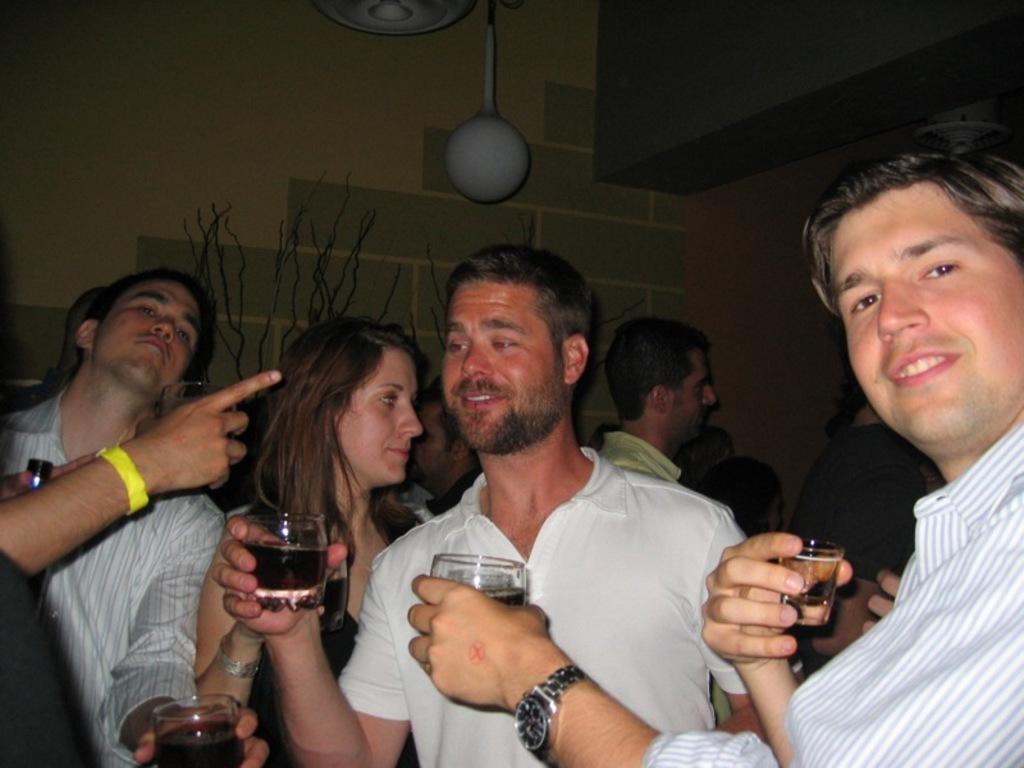Can you describe this image briefly? In this picture there are people, among them few people holding glasses with drink. In the background of the image we can see decorative objects and wall. 